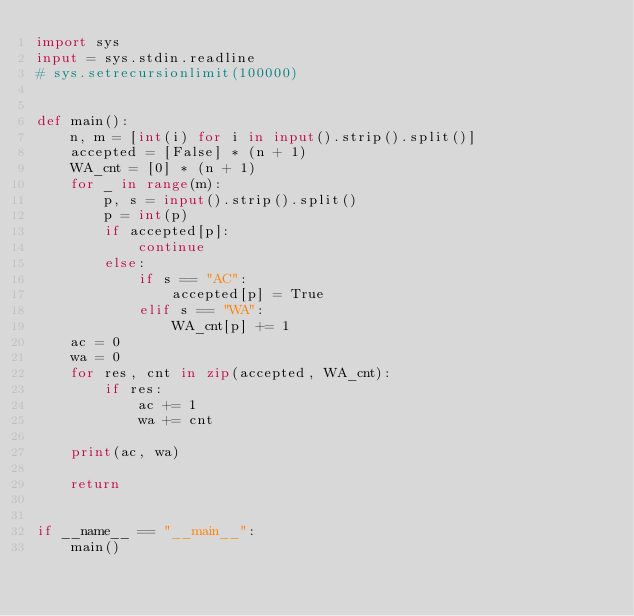Convert code to text. <code><loc_0><loc_0><loc_500><loc_500><_Python_>import sys
input = sys.stdin.readline
# sys.setrecursionlimit(100000)


def main():
    n, m = [int(i) for i in input().strip().split()]
    accepted = [False] * (n + 1)
    WA_cnt = [0] * (n + 1)
    for _ in range(m):
        p, s = input().strip().split()
        p = int(p)
        if accepted[p]:
            continue
        else:
            if s == "AC":
                accepted[p] = True
            elif s == "WA":
                WA_cnt[p] += 1
    ac = 0
    wa = 0
    for res, cnt in zip(accepted, WA_cnt):
        if res:
            ac += 1
            wa += cnt

    print(ac, wa)

    return


if __name__ == "__main__":
    main()
</code> 